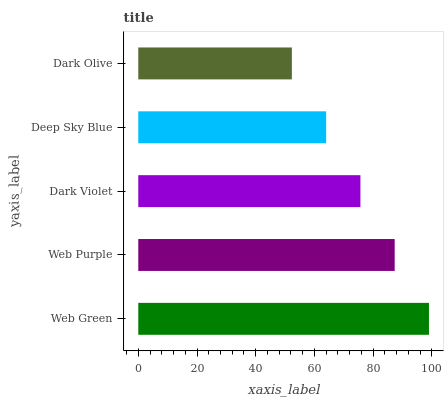Is Dark Olive the minimum?
Answer yes or no. Yes. Is Web Green the maximum?
Answer yes or no. Yes. Is Web Purple the minimum?
Answer yes or no. No. Is Web Purple the maximum?
Answer yes or no. No. Is Web Green greater than Web Purple?
Answer yes or no. Yes. Is Web Purple less than Web Green?
Answer yes or no. Yes. Is Web Purple greater than Web Green?
Answer yes or no. No. Is Web Green less than Web Purple?
Answer yes or no. No. Is Dark Violet the high median?
Answer yes or no. Yes. Is Dark Violet the low median?
Answer yes or no. Yes. Is Web Purple the high median?
Answer yes or no. No. Is Dark Olive the low median?
Answer yes or no. No. 